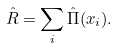Convert formula to latex. <formula><loc_0><loc_0><loc_500><loc_500>\hat { R } = \sum _ { i } \hat { \Pi } ( x _ { i } ) .</formula> 